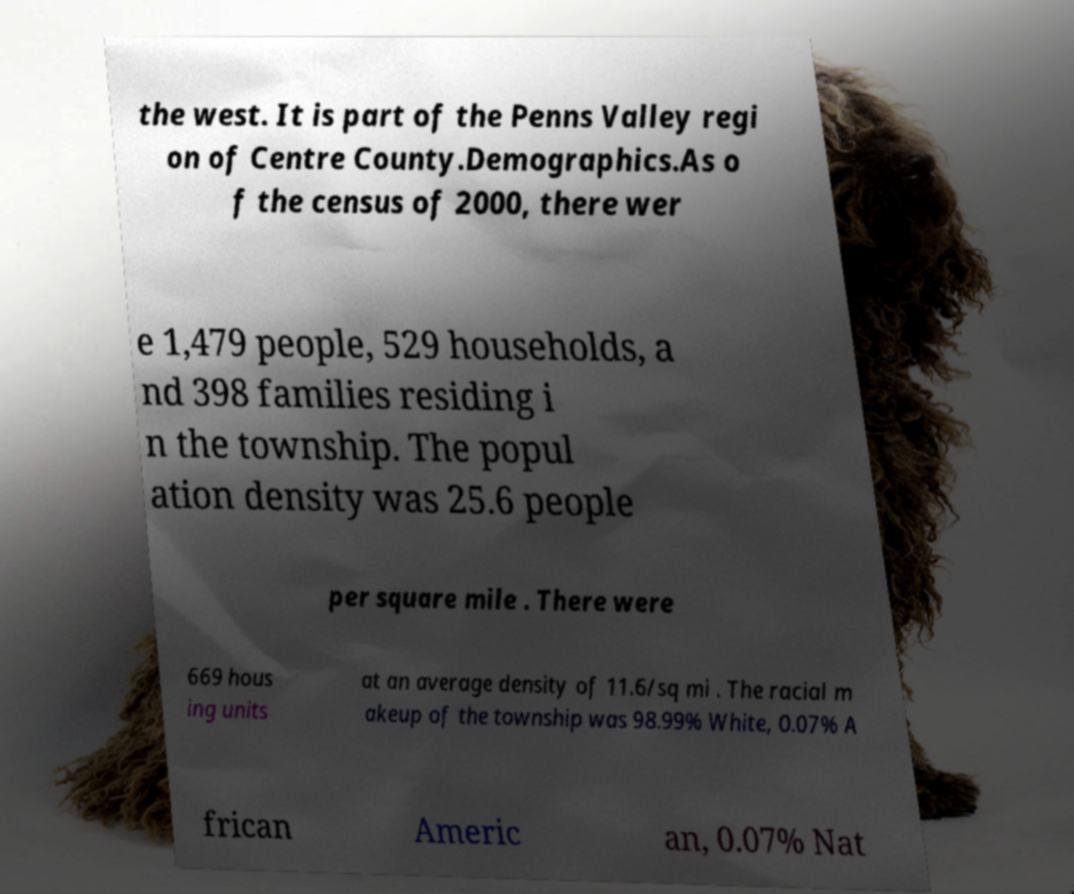What messages or text are displayed in this image? I need them in a readable, typed format. the west. It is part of the Penns Valley regi on of Centre County.Demographics.As o f the census of 2000, there wer e 1,479 people, 529 households, a nd 398 families residing i n the township. The popul ation density was 25.6 people per square mile . There were 669 hous ing units at an average density of 11.6/sq mi . The racial m akeup of the township was 98.99% White, 0.07% A frican Americ an, 0.07% Nat 